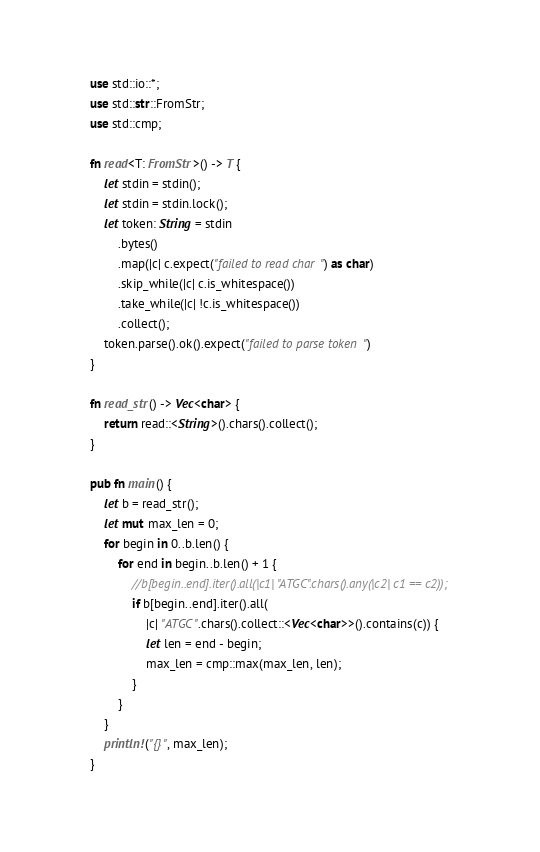<code> <loc_0><loc_0><loc_500><loc_500><_Rust_>use std::io::*;
use std::str::FromStr;
use std::cmp;

fn read<T: FromStr>() -> T {
    let stdin = stdin();
    let stdin = stdin.lock();
    let token: String = stdin
        .bytes()
        .map(|c| c.expect("failed to read char") as char)
        .skip_while(|c| c.is_whitespace())
        .take_while(|c| !c.is_whitespace())
        .collect();
    token.parse().ok().expect("failed to parse token")
}

fn read_str() -> Vec<char> {
    return read::<String>().chars().collect();
}

pub fn main() {
    let b = read_str();
    let mut max_len = 0;
    for begin in 0..b.len() {
        for end in begin..b.len() + 1 {
            //b[begin..end].iter().all(|c1| "ATGC".chars().any(|c2| c1 == c2));
            if b[begin..end].iter().all(
                |c| "ATGC".chars().collect::<Vec<char>>().contains(c)) {
                let len = end - begin;
                max_len = cmp::max(max_len, len);
            }
        }
    }
    println!("{}", max_len);
}
</code> 